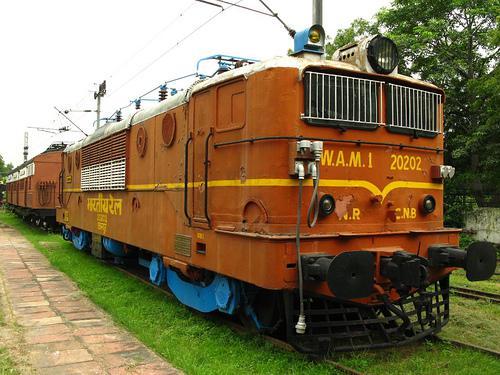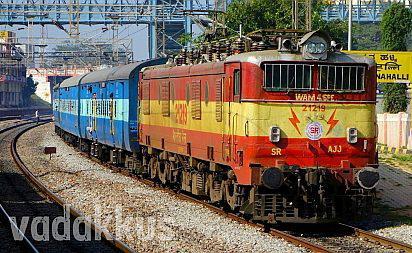The first image is the image on the left, the second image is the image on the right. For the images shown, is this caption "In one image a train locomotive at the front is painted in different two-tone colors than the one or more train cars that are behind it." true? Answer yes or no. Yes. The first image is the image on the left, the second image is the image on the right. Analyze the images presented: Is the assertion "Both trains are moving toward the right." valid? Answer yes or no. Yes. 